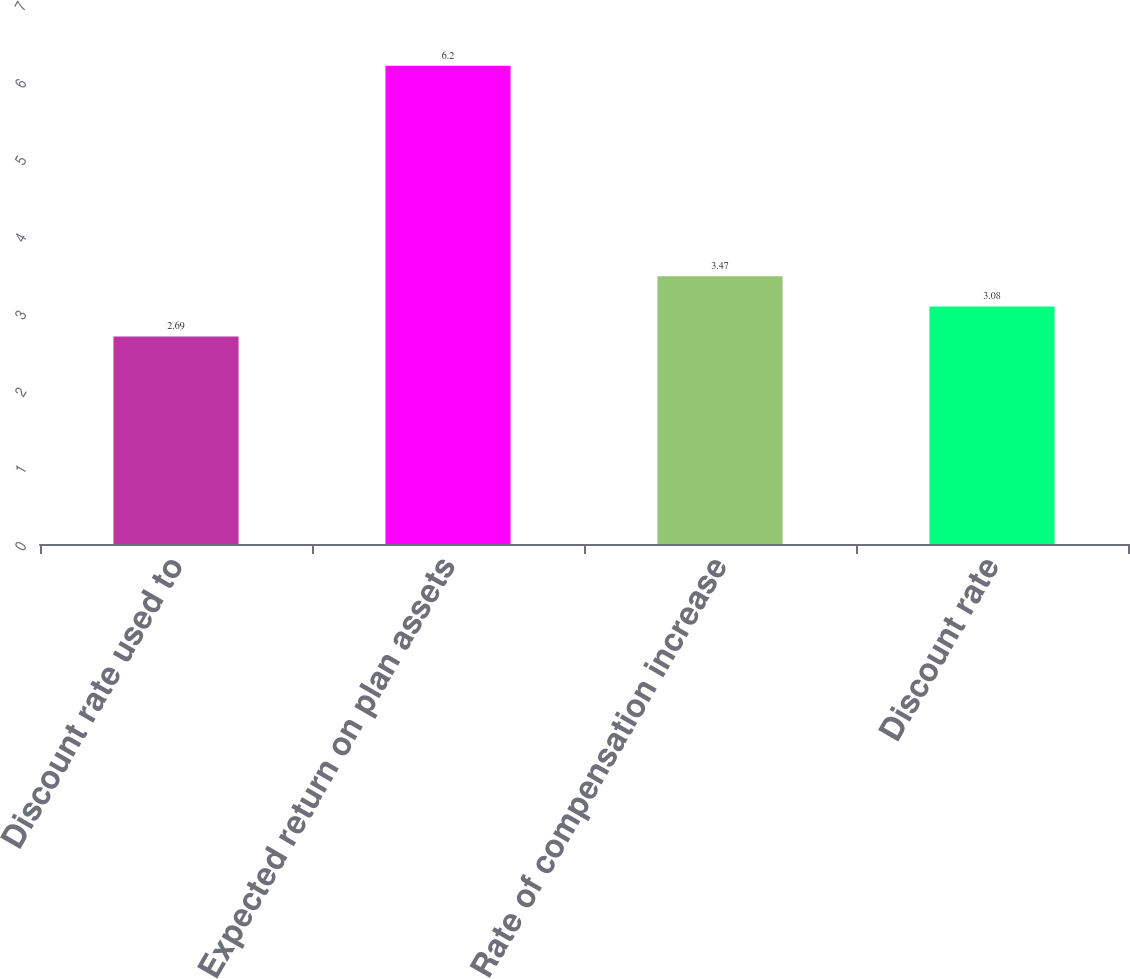Convert chart. <chart><loc_0><loc_0><loc_500><loc_500><bar_chart><fcel>Discount rate used to<fcel>Expected return on plan assets<fcel>Rate of compensation increase<fcel>Discount rate<nl><fcel>2.69<fcel>6.2<fcel>3.47<fcel>3.08<nl></chart> 